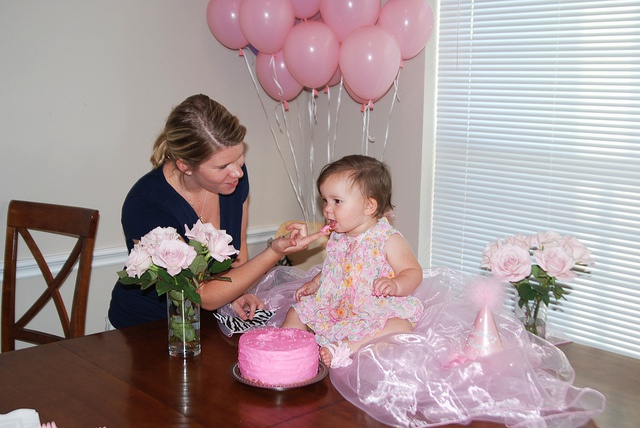Describe the objects in this image and their specific colors. I can see dining table in darkgray, maroon, black, lightgray, and lightpink tones, people in darkgray, black, brown, and maroon tones, people in darkgray, lightpink, lightgray, and pink tones, chair in darkgray, maroon, black, and gray tones, and cake in darkgray, lightpink, violet, and brown tones in this image. 